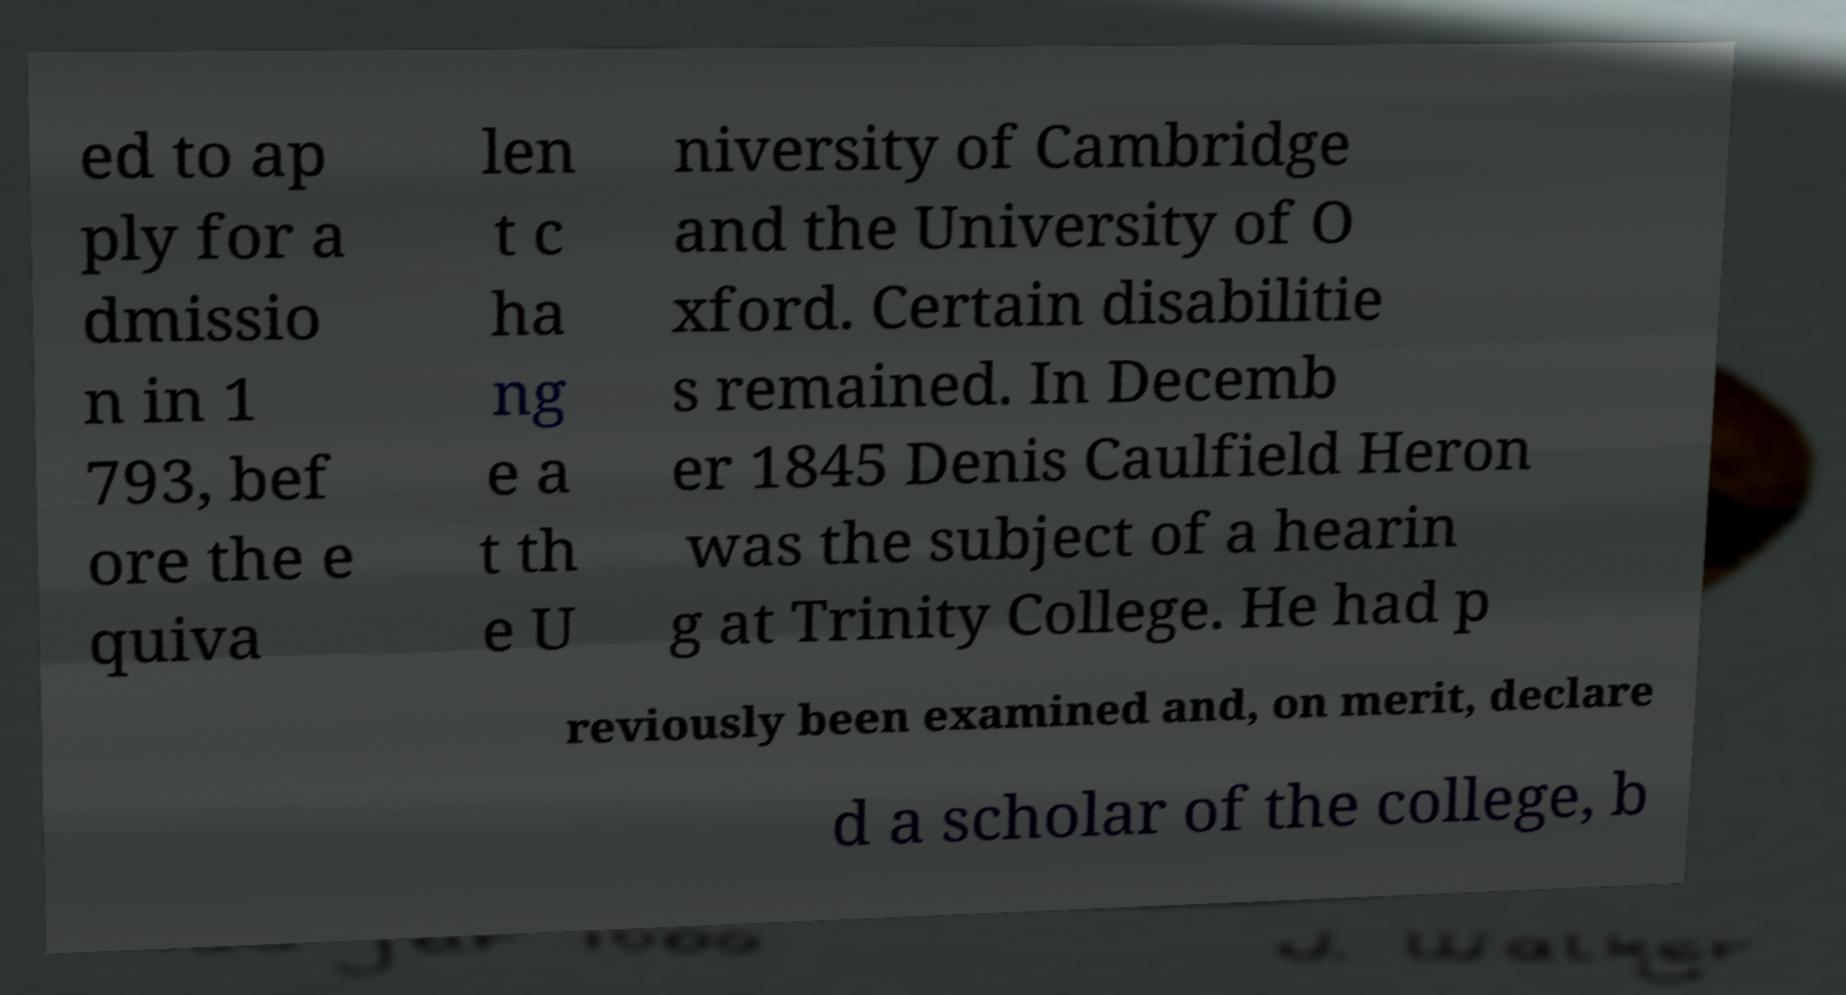Can you accurately transcribe the text from the provided image for me? ed to ap ply for a dmissio n in 1 793, bef ore the e quiva len t c ha ng e a t th e U niversity of Cambridge and the University of O xford. Certain disabilitie s remained. In Decemb er 1845 Denis Caulfield Heron was the subject of a hearin g at Trinity College. He had p reviously been examined and, on merit, declare d a scholar of the college, b 